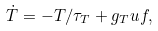Convert formula to latex. <formula><loc_0><loc_0><loc_500><loc_500>\dot { T } = - T / \tau _ { T } + g _ { T } u f ,</formula> 